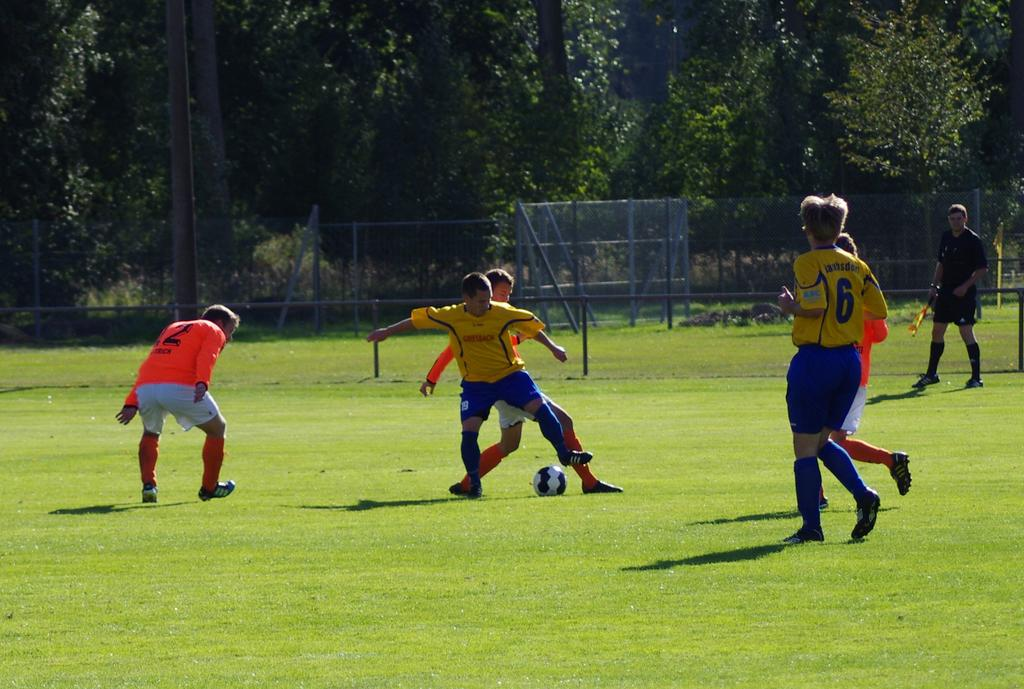<image>
Present a compact description of the photo's key features. A boy with the jersey number six runs on a soccer field. 